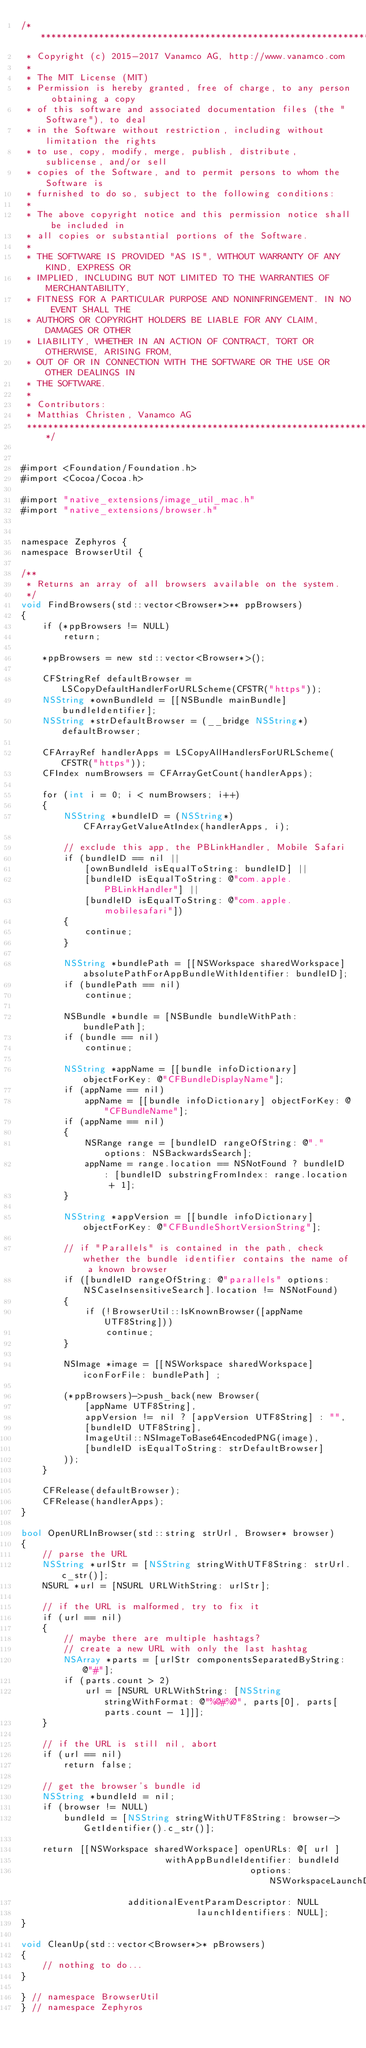Convert code to text. <code><loc_0><loc_0><loc_500><loc_500><_ObjectiveC_>/*******************************************************************************
 * Copyright (c) 2015-2017 Vanamco AG, http://www.vanamco.com
 *
 * The MIT License (MIT)
 * Permission is hereby granted, free of charge, to any person obtaining a copy
 * of this software and associated documentation files (the "Software"), to deal
 * in the Software without restriction, including without limitation the rights
 * to use, copy, modify, merge, publish, distribute, sublicense, and/or sell
 * copies of the Software, and to permit persons to whom the Software is
 * furnished to do so, subject to the following conditions:
 *
 * The above copyright notice and this permission notice shall be included in
 * all copies or substantial portions of the Software.
 *
 * THE SOFTWARE IS PROVIDED "AS IS", WITHOUT WARRANTY OF ANY KIND, EXPRESS OR
 * IMPLIED, INCLUDING BUT NOT LIMITED TO THE WARRANTIES OF MERCHANTABILITY,
 * FITNESS FOR A PARTICULAR PURPOSE AND NONINFRINGEMENT. IN NO EVENT SHALL THE
 * AUTHORS OR COPYRIGHT HOLDERS BE LIABLE FOR ANY CLAIM, DAMAGES OR OTHER
 * LIABILITY, WHETHER IN AN ACTION OF CONTRACT, TORT OR OTHERWISE, ARISING FROM,
 * OUT OF OR IN CONNECTION WITH THE SOFTWARE OR THE USE OR OTHER DEALINGS IN
 * THE SOFTWARE.
 *
 * Contributors:
 * Matthias Christen, Vanamco AG
 *******************************************************************************/


#import <Foundation/Foundation.h>
#import <Cocoa/Cocoa.h>

#import "native_extensions/image_util_mac.h"
#import "native_extensions/browser.h"


namespace Zephyros {
namespace BrowserUtil {

/**
 * Returns an array of all browsers available on the system.
 */
void FindBrowsers(std::vector<Browser*>** ppBrowsers)
{
    if (*ppBrowsers != NULL)
        return;
    
    *ppBrowsers = new std::vector<Browser*>();
    
    CFStringRef defaultBrowser = LSCopyDefaultHandlerForURLScheme(CFSTR("https"));
    NSString *ownBundleId = [[NSBundle mainBundle] bundleIdentifier];
    NSString *strDefaultBrowser = (__bridge NSString*) defaultBrowser;
    
    CFArrayRef handlerApps = LSCopyAllHandlersForURLScheme(CFSTR("https"));
    CFIndex numBrowsers = CFArrayGetCount(handlerApps);
        
    for (int i = 0; i < numBrowsers; i++)
    {
        NSString *bundleID = (NSString*) CFArrayGetValueAtIndex(handlerApps, i);
            
        // exclude this app, the PBLinkHandler, Mobile Safari
        if (bundleID == nil ||
            [ownBundleId isEqualToString: bundleID] ||
            [bundleID isEqualToString: @"com.apple.PBLinkHandler"] ||
            [bundleID isEqualToString: @"com.apple.mobilesafari"])
        {
            continue;
        }

        NSString *bundlePath = [[NSWorkspace sharedWorkspace] absolutePathForAppBundleWithIdentifier: bundleID];
        if (bundlePath == nil)
            continue;
        
        NSBundle *bundle = [NSBundle bundleWithPath: bundlePath];
        if (bundle == nil)
            continue;
            
        NSString *appName = [[bundle infoDictionary] objectForKey: @"CFBundleDisplayName"];
        if (appName == nil)
            appName = [[bundle infoDictionary] objectForKey: @"CFBundleName"];
        if (appName == nil)
        {
            NSRange range = [bundleID rangeOfString: @"." options: NSBackwardsSearch];
            appName = range.location == NSNotFound ? bundleID : [bundleID substringFromIndex: range.location + 1];
        }
        
        NSString *appVersion = [[bundle infoDictionary] objectForKey: @"CFBundleShortVersionString"];

        // if "Parallels" is contained in the path, check whether the bundle identifier contains the name of a known browser
        if ([bundleID rangeOfString: @"parallels" options: NSCaseInsensitiveSearch].location != NSNotFound)
        {
            if (!BrowserUtil::IsKnownBrowser([appName UTF8String]))
                continue;
        }
        
        NSImage *image = [[NSWorkspace sharedWorkspace] iconForFile: bundlePath] ;
        
        (*ppBrowsers)->push_back(new Browser(
            [appName UTF8String],
            appVersion != nil ? [appVersion UTF8String] : "",
            [bundleID UTF8String],
            ImageUtil::NSImageToBase64EncodedPNG(image),
            [bundleID isEqualToString: strDefaultBrowser]
        ));
    }
        
    CFRelease(defaultBrowser);
    CFRelease(handlerApps);
}

bool OpenURLInBrowser(std::string strUrl, Browser* browser)
{
    // parse the URL
    NSString *urlStr = [NSString stringWithUTF8String: strUrl.c_str()];
    NSURL *url = [NSURL URLWithString: urlStr];

    // if the URL is malformed, try to fix it
    if (url == nil)
    {
        // maybe there are multiple hashtags?
        // create a new URL with only the last hashtag
        NSArray *parts = [urlStr componentsSeparatedByString: @"#"];
        if (parts.count > 2)
            url = [NSURL URLWithString: [NSString stringWithFormat: @"%@#%@", parts[0], parts[parts.count - 1]]];
    }

    // if the URL is still nil, abort
    if (url == nil)
        return false;

    // get the browser's bundle id
    NSString *bundleId = nil;
    if (browser != NULL)
        bundleId = [NSString stringWithUTF8String: browser->GetIdentifier().c_str()];
    
    return [[NSWorkspace sharedWorkspace] openURLs: @[ url ]
                           withAppBundleIdentifier: bundleId
                                           options: NSWorkspaceLaunchDefault
                    additionalEventParamDescriptor: NULL
                                 launchIdentifiers: NULL];
}

void CleanUp(std::vector<Browser*>* pBrowsers)
{
    // nothing to do...
}

} // namespace BrowserUtil
} // namespace Zephyros
</code> 